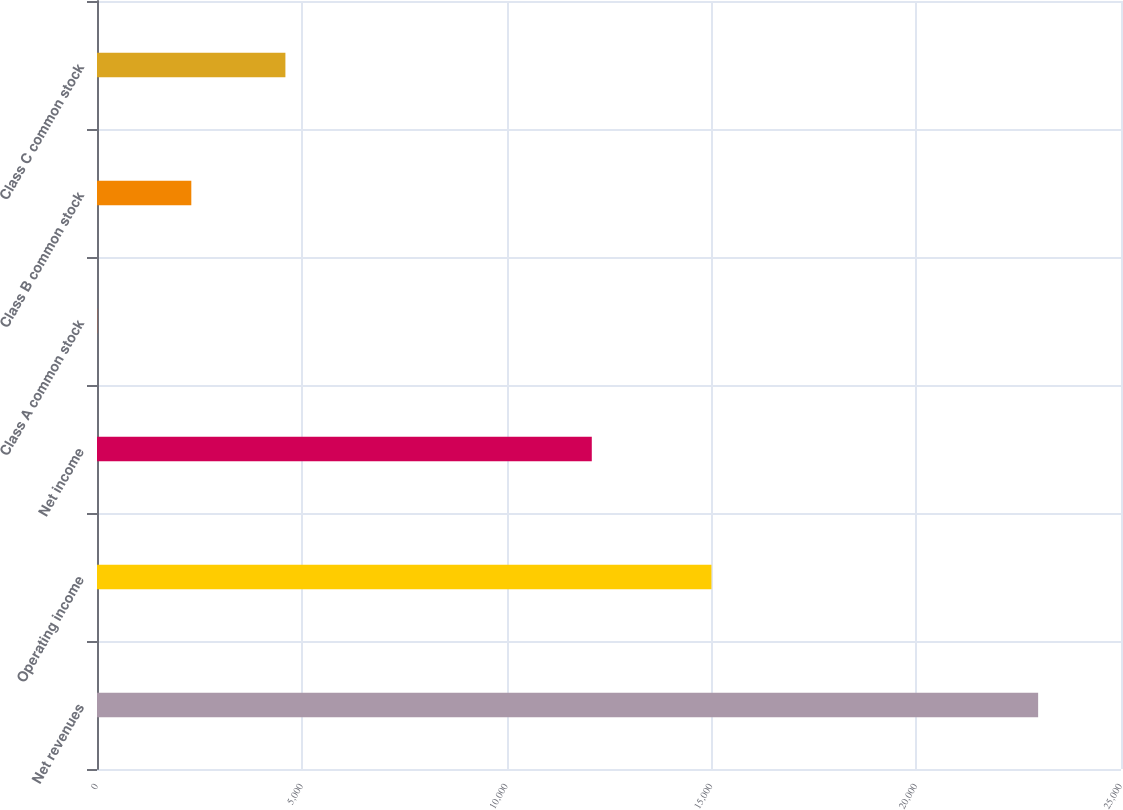Convert chart to OTSL. <chart><loc_0><loc_0><loc_500><loc_500><bar_chart><fcel>Net revenues<fcel>Operating income<fcel>Net income<fcel>Class A common stock<fcel>Class B common stock<fcel>Class C common stock<nl><fcel>22977<fcel>15001<fcel>12080<fcel>5.32<fcel>2302.49<fcel>4599.66<nl></chart> 